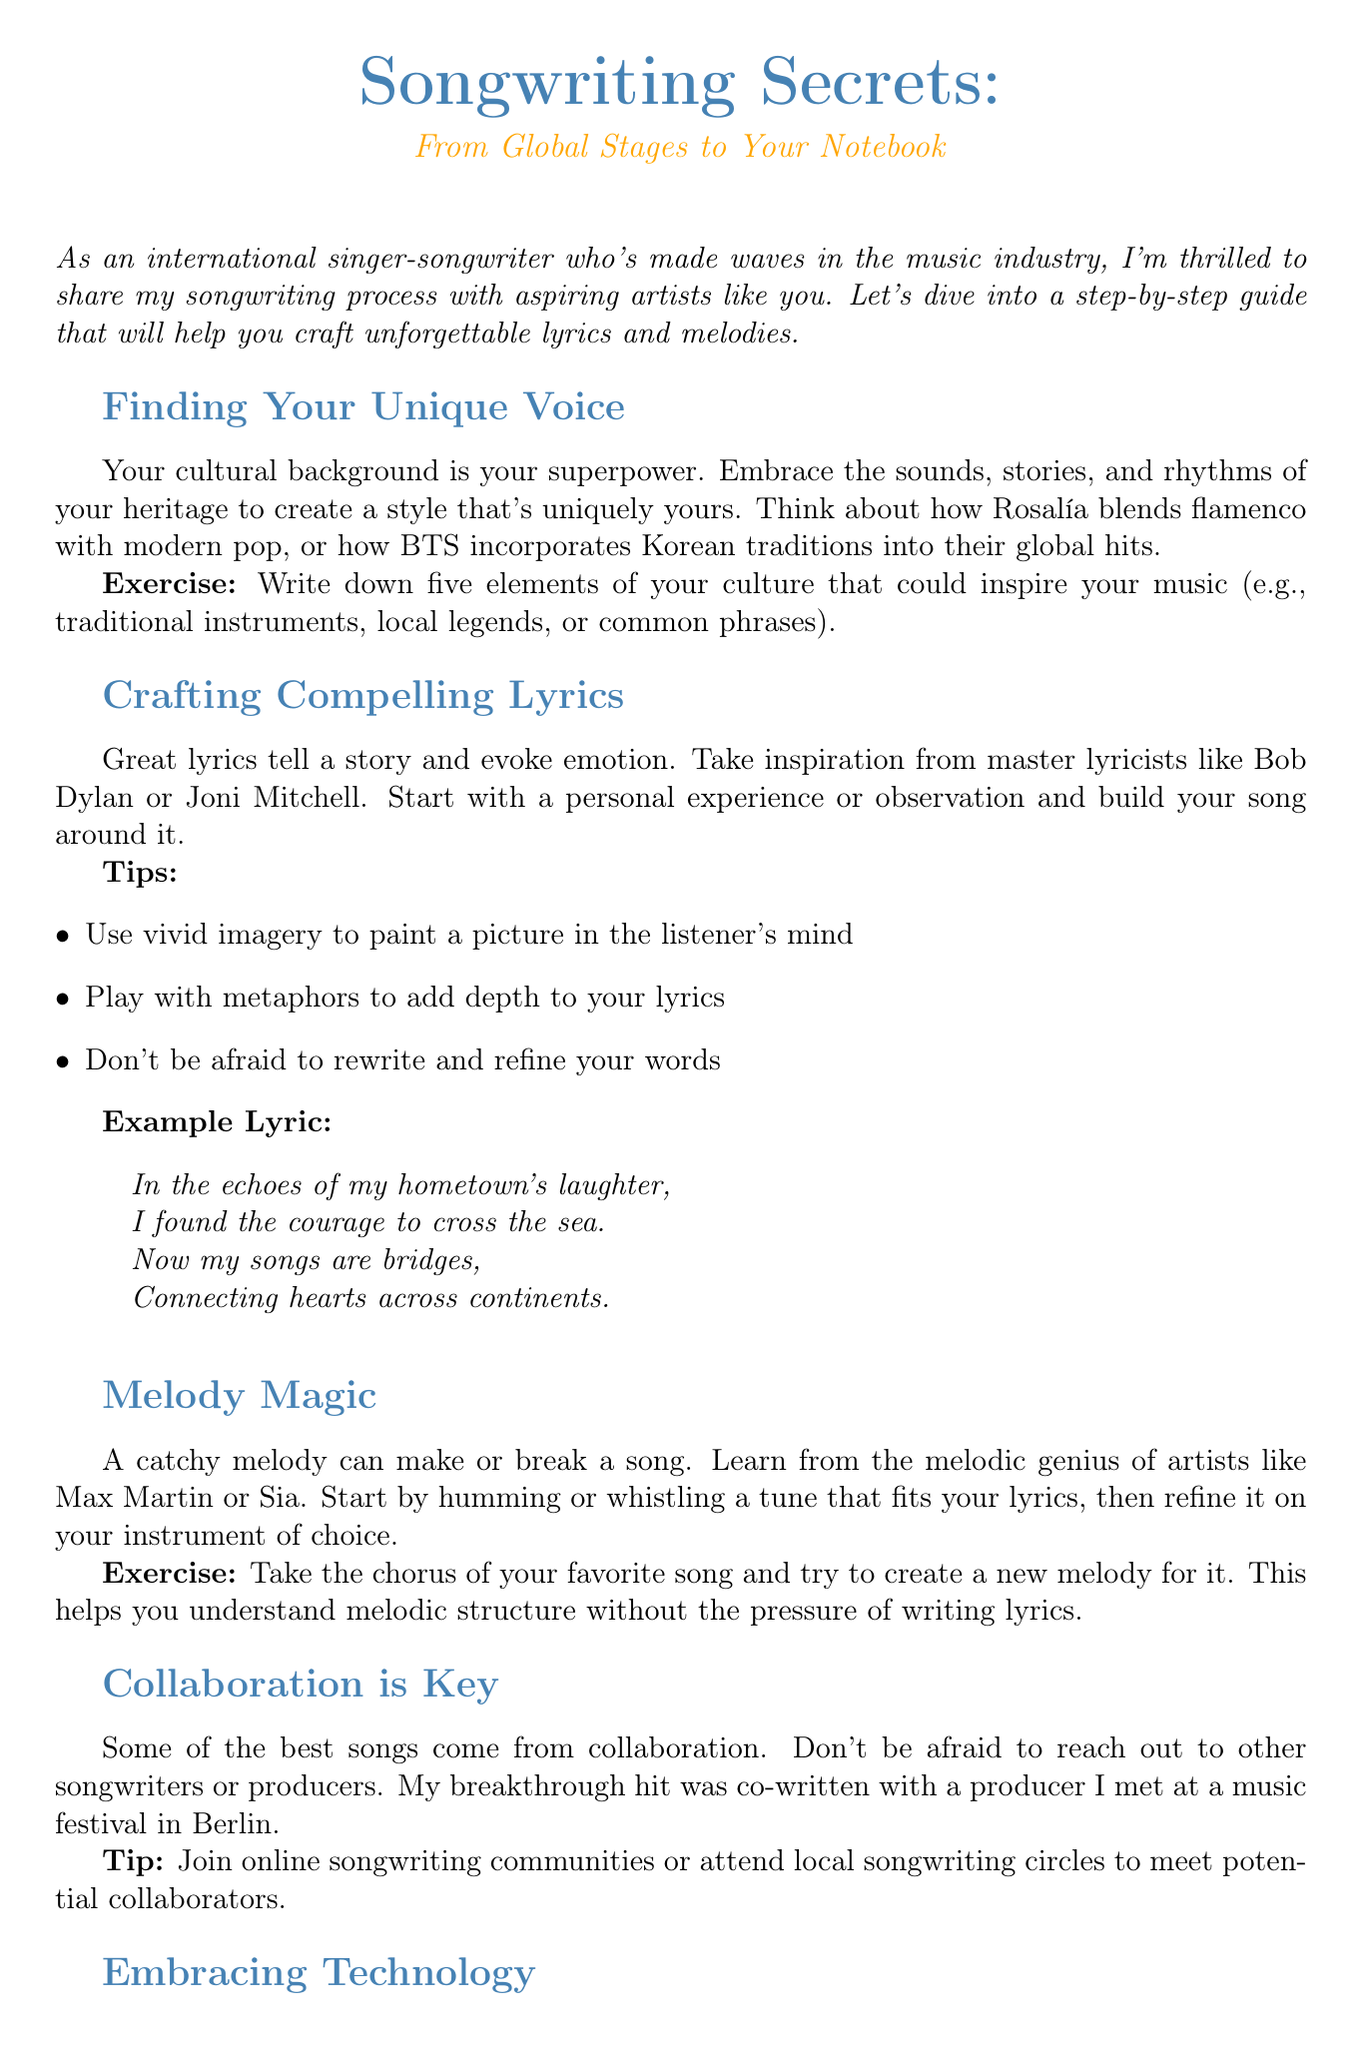What is the title of the newsletter? The title is presented at the beginning of the document, which is "Songwriting Secrets: From Global Stages to Your Notebook."
Answer: Songwriting Secrets: From Global Stages to Your Notebook Who is the author of the newsletter? The author is introduced in the introduction section, noted as an international singer-songwriter.
Answer: International singer-songwriter What is one of the resources mentioned for modern songwriting? Resources are listed under the section "Embracing Technology"; one of them is specified as Splice.com.
Answer: Splice.com In which section can tips for crafting lyrics be found? The tips are detailed in the section titled "Crafting Compelling Lyrics."
Answer: Crafting Compelling Lyrics What does the exercise in the "Finding Your Unique Voice" section ask you to do? The exercise asks to write down five elements of your culture that could inspire your music.
Answer: Write down five elements of your culture How does the document suggest improving melody skills? The document suggests recreating a new melody for the chorus of a favorite song to understand melodic structure.
Answer: Create a new melody for the chorus What is the main purpose of the document? The main purpose is to help aspiring songwriters craft unforgettable lyrics and melodies.
Answer: Help aspiring songwriters craft unforgettable lyrics and melodies What is the call to action presented in the newsletter? The call to action encourages readers to join an exclusive online workshop for personalized feedback.
Answer: Join my exclusive online workshop 